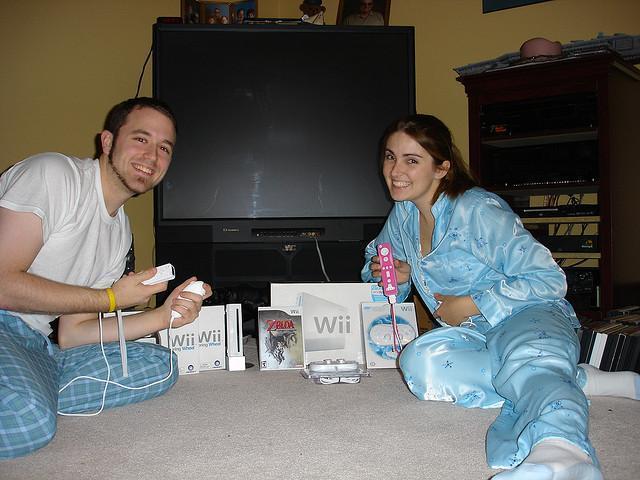Who is the main male character in that video game?
From the following set of four choices, select the accurate answer to respond to the question.
Options: Link, kong, zelda, mario. Link. 